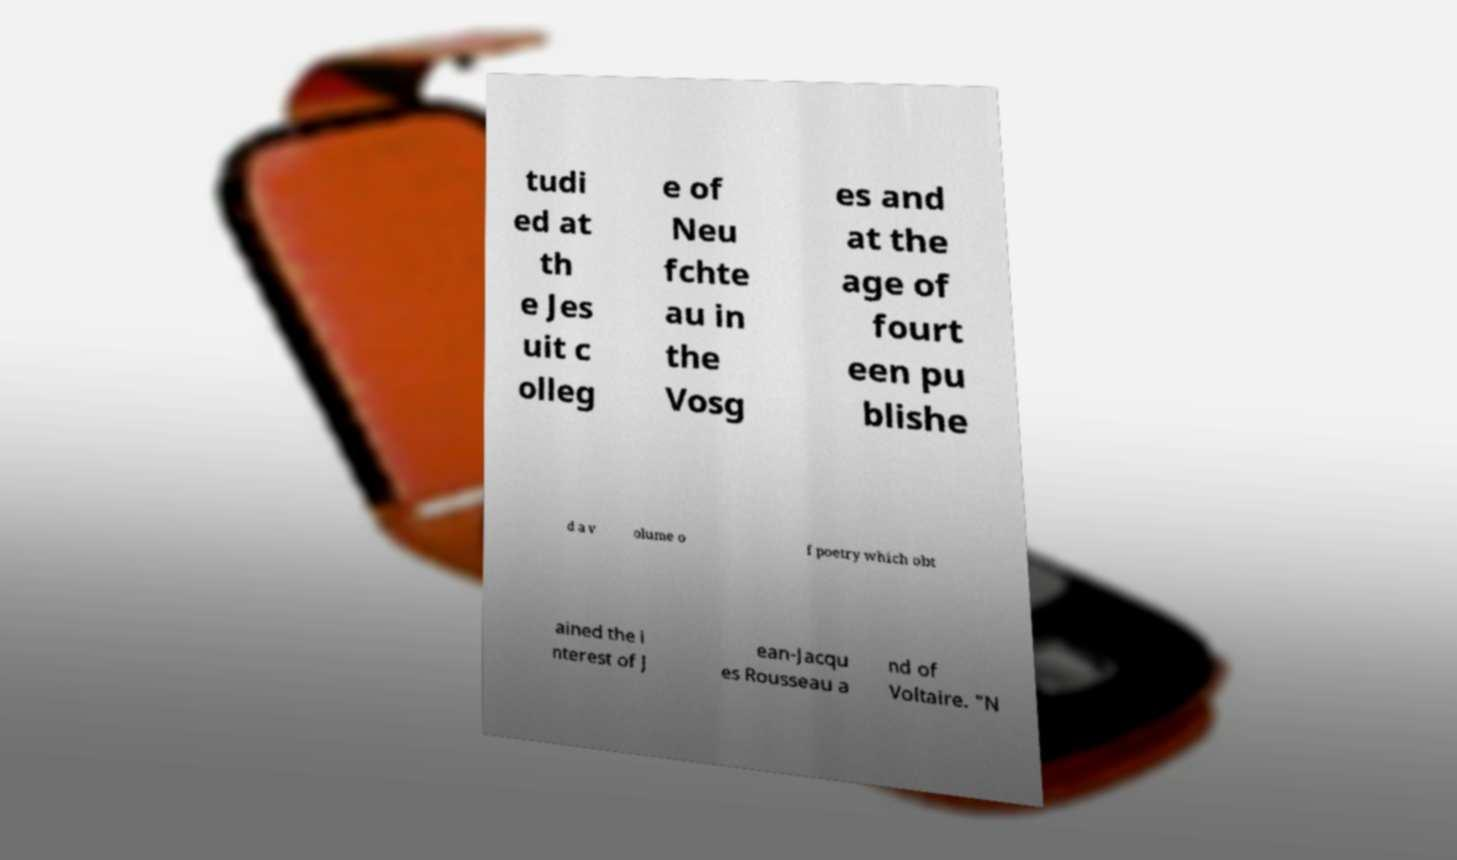For documentation purposes, I need the text within this image transcribed. Could you provide that? tudi ed at th e Jes uit c olleg e of Neu fchte au in the Vosg es and at the age of fourt een pu blishe d a v olume o f poetry which obt ained the i nterest of J ean-Jacqu es Rousseau a nd of Voltaire. "N 